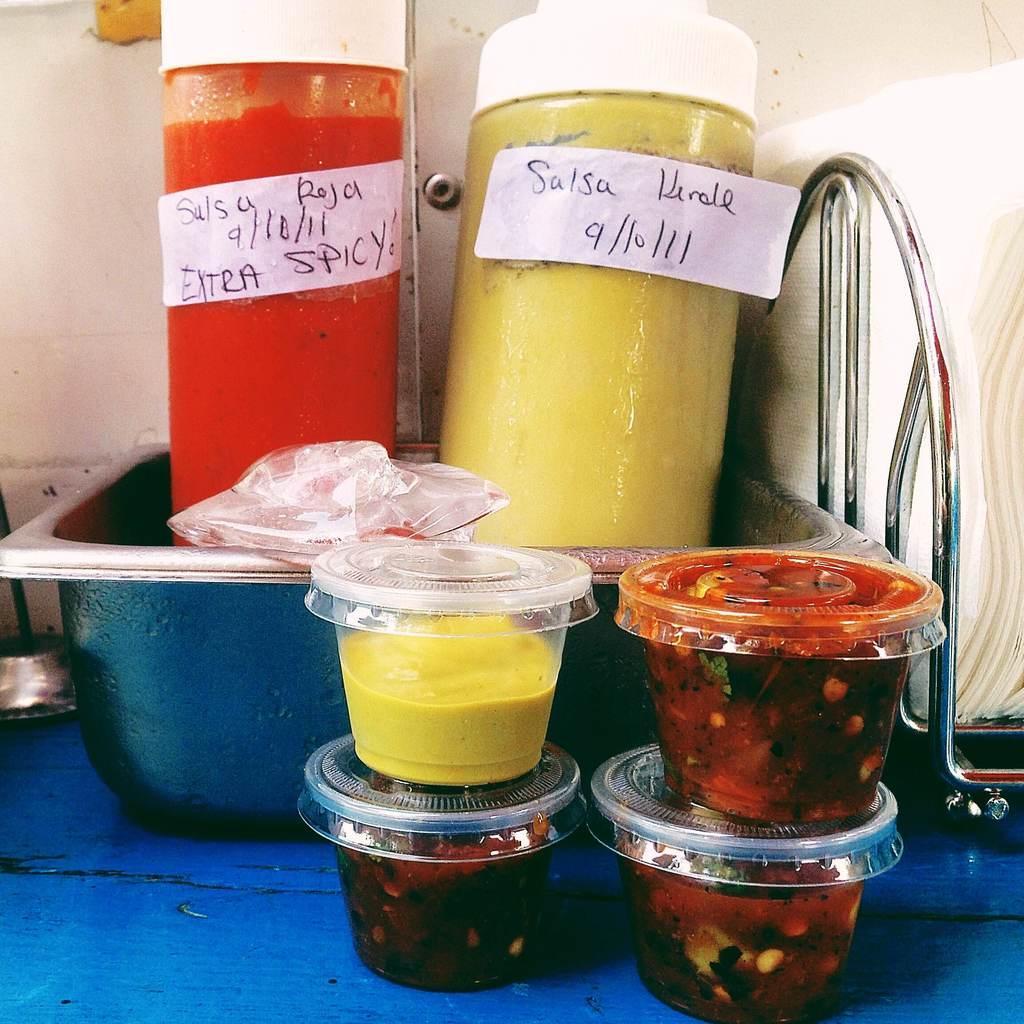Can you describe this image briefly? In this picture we can see a vessel and on the vessel we have spicy and salsa bottles and in front of this we have some jars with some food and aside to this we have tissues stand and in the background we can see wall. 